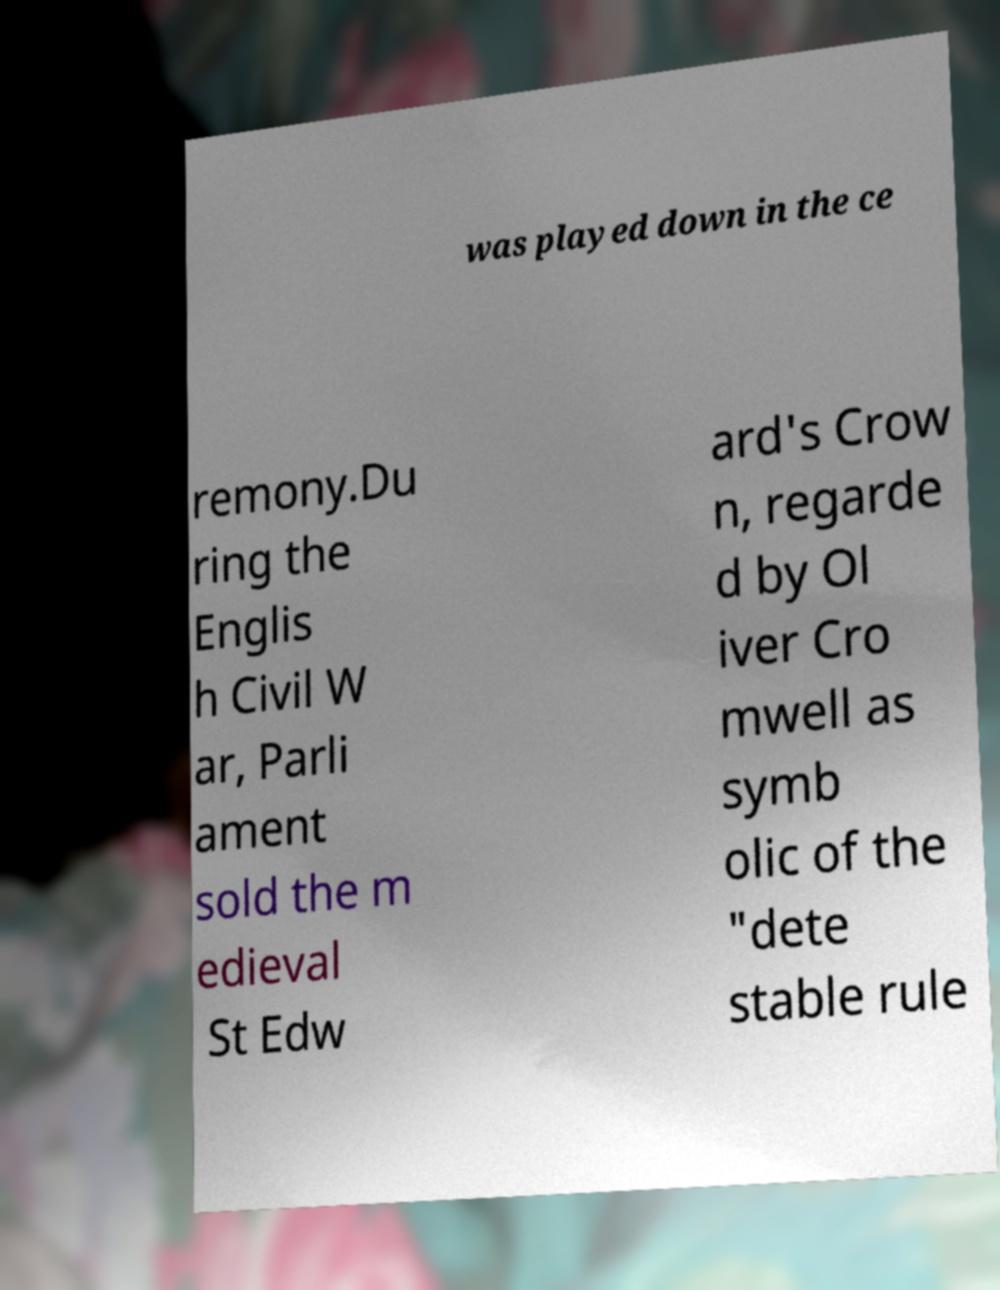There's text embedded in this image that I need extracted. Can you transcribe it verbatim? was played down in the ce remony.Du ring the Englis h Civil W ar, Parli ament sold the m edieval St Edw ard's Crow n, regarde d by Ol iver Cro mwell as symb olic of the "dete stable rule 